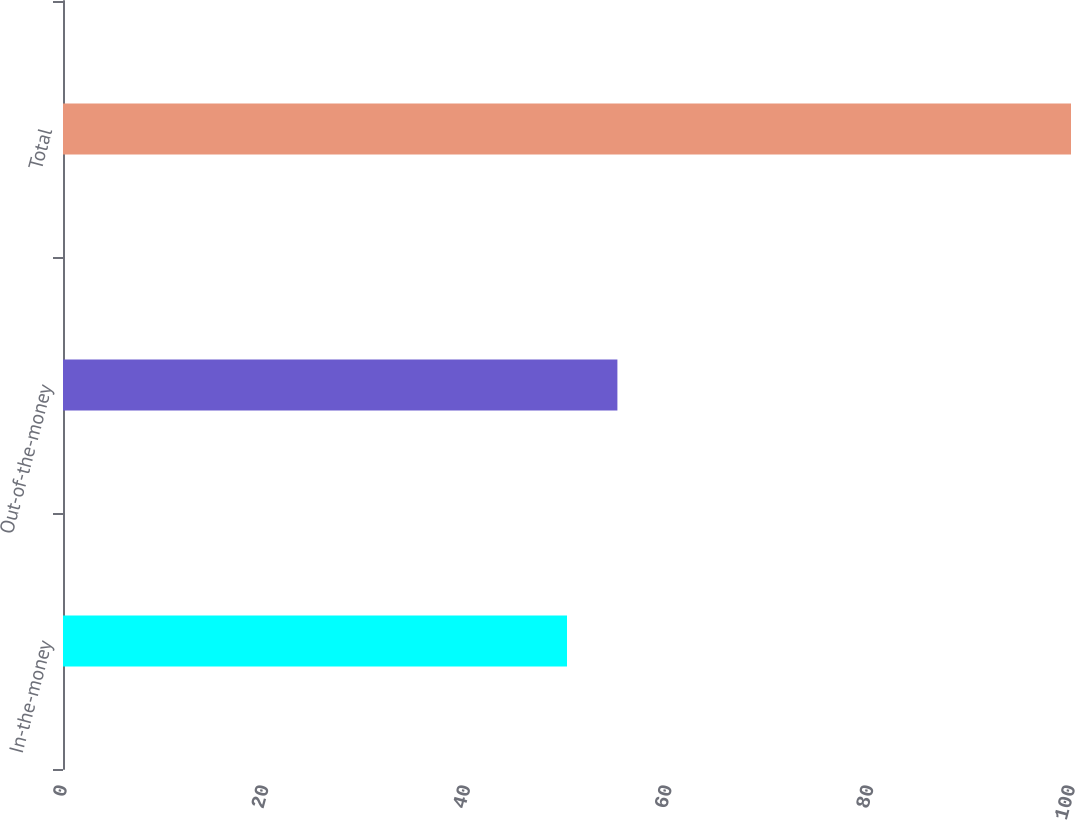<chart> <loc_0><loc_0><loc_500><loc_500><bar_chart><fcel>In-the-money<fcel>Out-of-the-money<fcel>Total<nl><fcel>50<fcel>55<fcel>100<nl></chart> 